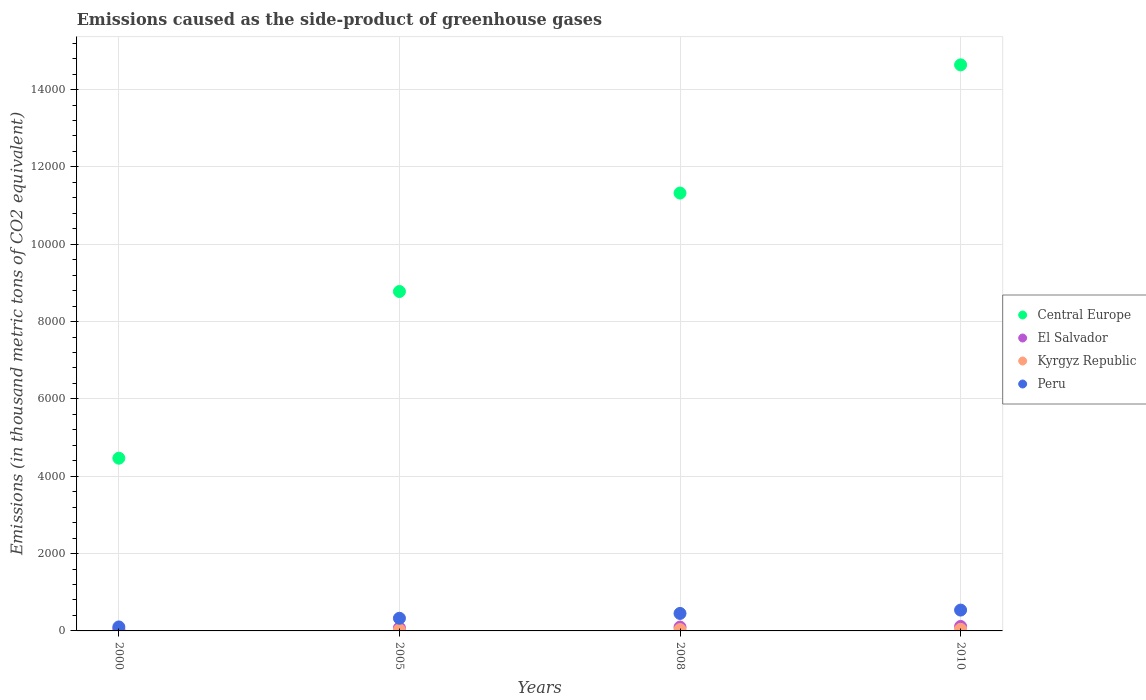Is the number of dotlines equal to the number of legend labels?
Keep it short and to the point. Yes. What is the emissions caused as the side-product of greenhouse gases in Peru in 2005?
Offer a very short reply. 327.6. Across all years, what is the maximum emissions caused as the side-product of greenhouse gases in El Salvador?
Offer a terse response. 116. Across all years, what is the minimum emissions caused as the side-product of greenhouse gases in Kyrgyz Republic?
Keep it short and to the point. 7.9. In which year was the emissions caused as the side-product of greenhouse gases in El Salvador maximum?
Offer a very short reply. 2010. In which year was the emissions caused as the side-product of greenhouse gases in Kyrgyz Republic minimum?
Provide a succinct answer. 2000. What is the total emissions caused as the side-product of greenhouse gases in Kyrgyz Republic in the graph?
Provide a succinct answer. 108.7. What is the difference between the emissions caused as the side-product of greenhouse gases in Central Europe in 2008 and that in 2010?
Make the answer very short. -3315.6. What is the difference between the emissions caused as the side-product of greenhouse gases in Kyrgyz Republic in 2005 and the emissions caused as the side-product of greenhouse gases in Central Europe in 2008?
Your answer should be compact. -1.13e+04. What is the average emissions caused as the side-product of greenhouse gases in El Salvador per year?
Give a very brief answer. 83.35. In the year 2010, what is the difference between the emissions caused as the side-product of greenhouse gases in Central Europe and emissions caused as the side-product of greenhouse gases in Peru?
Offer a terse response. 1.41e+04. What is the ratio of the emissions caused as the side-product of greenhouse gases in El Salvador in 2000 to that in 2008?
Offer a very short reply. 0.42. Is the emissions caused as the side-product of greenhouse gases in Central Europe in 2008 less than that in 2010?
Keep it short and to the point. Yes. Is the difference between the emissions caused as the side-product of greenhouse gases in Central Europe in 2005 and 2010 greater than the difference between the emissions caused as the side-product of greenhouse gases in Peru in 2005 and 2010?
Make the answer very short. No. What is the difference between the highest and the second highest emissions caused as the side-product of greenhouse gases in Central Europe?
Provide a short and direct response. 3315.6. What is the difference between the highest and the lowest emissions caused as the side-product of greenhouse gases in Central Europe?
Your response must be concise. 1.02e+04. In how many years, is the emissions caused as the side-product of greenhouse gases in Kyrgyz Republic greater than the average emissions caused as the side-product of greenhouse gases in Kyrgyz Republic taken over all years?
Your response must be concise. 2. Is it the case that in every year, the sum of the emissions caused as the side-product of greenhouse gases in Central Europe and emissions caused as the side-product of greenhouse gases in Kyrgyz Republic  is greater than the sum of emissions caused as the side-product of greenhouse gases in Peru and emissions caused as the side-product of greenhouse gases in El Salvador?
Your response must be concise. Yes. Is the emissions caused as the side-product of greenhouse gases in Central Europe strictly greater than the emissions caused as the side-product of greenhouse gases in Peru over the years?
Keep it short and to the point. Yes. Is the emissions caused as the side-product of greenhouse gases in Kyrgyz Republic strictly less than the emissions caused as the side-product of greenhouse gases in Peru over the years?
Make the answer very short. Yes. How many dotlines are there?
Offer a very short reply. 4. How many years are there in the graph?
Ensure brevity in your answer.  4. Does the graph contain any zero values?
Offer a terse response. No. How are the legend labels stacked?
Provide a succinct answer. Vertical. What is the title of the graph?
Give a very brief answer. Emissions caused as the side-product of greenhouse gases. What is the label or title of the X-axis?
Give a very brief answer. Years. What is the label or title of the Y-axis?
Your answer should be very brief. Emissions (in thousand metric tons of CO2 equivalent). What is the Emissions (in thousand metric tons of CO2 equivalent) in Central Europe in 2000?
Keep it short and to the point. 4466.9. What is the Emissions (in thousand metric tons of CO2 equivalent) of El Salvador in 2000?
Keep it short and to the point. 41.4. What is the Emissions (in thousand metric tons of CO2 equivalent) of Peru in 2000?
Your response must be concise. 103.1. What is the Emissions (in thousand metric tons of CO2 equivalent) in Central Europe in 2005?
Give a very brief answer. 8777.6. What is the Emissions (in thousand metric tons of CO2 equivalent) of El Salvador in 2005?
Keep it short and to the point. 76.4. What is the Emissions (in thousand metric tons of CO2 equivalent) of Peru in 2005?
Your response must be concise. 327.6. What is the Emissions (in thousand metric tons of CO2 equivalent) of Central Europe in 2008?
Offer a terse response. 1.13e+04. What is the Emissions (in thousand metric tons of CO2 equivalent) of El Salvador in 2008?
Offer a terse response. 99.6. What is the Emissions (in thousand metric tons of CO2 equivalent) in Kyrgyz Republic in 2008?
Give a very brief answer. 34.8. What is the Emissions (in thousand metric tons of CO2 equivalent) of Peru in 2008?
Your response must be concise. 452. What is the Emissions (in thousand metric tons of CO2 equivalent) in Central Europe in 2010?
Offer a terse response. 1.46e+04. What is the Emissions (in thousand metric tons of CO2 equivalent) of El Salvador in 2010?
Your answer should be very brief. 116. What is the Emissions (in thousand metric tons of CO2 equivalent) in Peru in 2010?
Provide a succinct answer. 539. Across all years, what is the maximum Emissions (in thousand metric tons of CO2 equivalent) in Central Europe?
Keep it short and to the point. 1.46e+04. Across all years, what is the maximum Emissions (in thousand metric tons of CO2 equivalent) of El Salvador?
Provide a succinct answer. 116. Across all years, what is the maximum Emissions (in thousand metric tons of CO2 equivalent) of Kyrgyz Republic?
Keep it short and to the point. 42. Across all years, what is the maximum Emissions (in thousand metric tons of CO2 equivalent) of Peru?
Ensure brevity in your answer.  539. Across all years, what is the minimum Emissions (in thousand metric tons of CO2 equivalent) of Central Europe?
Give a very brief answer. 4466.9. Across all years, what is the minimum Emissions (in thousand metric tons of CO2 equivalent) in El Salvador?
Offer a very short reply. 41.4. Across all years, what is the minimum Emissions (in thousand metric tons of CO2 equivalent) of Kyrgyz Republic?
Provide a succinct answer. 7.9. Across all years, what is the minimum Emissions (in thousand metric tons of CO2 equivalent) of Peru?
Provide a succinct answer. 103.1. What is the total Emissions (in thousand metric tons of CO2 equivalent) of Central Europe in the graph?
Give a very brief answer. 3.92e+04. What is the total Emissions (in thousand metric tons of CO2 equivalent) of El Salvador in the graph?
Provide a succinct answer. 333.4. What is the total Emissions (in thousand metric tons of CO2 equivalent) in Kyrgyz Republic in the graph?
Your response must be concise. 108.7. What is the total Emissions (in thousand metric tons of CO2 equivalent) in Peru in the graph?
Your answer should be compact. 1421.7. What is the difference between the Emissions (in thousand metric tons of CO2 equivalent) of Central Europe in 2000 and that in 2005?
Offer a terse response. -4310.7. What is the difference between the Emissions (in thousand metric tons of CO2 equivalent) of El Salvador in 2000 and that in 2005?
Provide a succinct answer. -35. What is the difference between the Emissions (in thousand metric tons of CO2 equivalent) of Kyrgyz Republic in 2000 and that in 2005?
Keep it short and to the point. -16.1. What is the difference between the Emissions (in thousand metric tons of CO2 equivalent) of Peru in 2000 and that in 2005?
Ensure brevity in your answer.  -224.5. What is the difference between the Emissions (in thousand metric tons of CO2 equivalent) in Central Europe in 2000 and that in 2008?
Ensure brevity in your answer.  -6856.5. What is the difference between the Emissions (in thousand metric tons of CO2 equivalent) in El Salvador in 2000 and that in 2008?
Give a very brief answer. -58.2. What is the difference between the Emissions (in thousand metric tons of CO2 equivalent) in Kyrgyz Republic in 2000 and that in 2008?
Ensure brevity in your answer.  -26.9. What is the difference between the Emissions (in thousand metric tons of CO2 equivalent) of Peru in 2000 and that in 2008?
Your answer should be very brief. -348.9. What is the difference between the Emissions (in thousand metric tons of CO2 equivalent) of Central Europe in 2000 and that in 2010?
Offer a terse response. -1.02e+04. What is the difference between the Emissions (in thousand metric tons of CO2 equivalent) in El Salvador in 2000 and that in 2010?
Your response must be concise. -74.6. What is the difference between the Emissions (in thousand metric tons of CO2 equivalent) in Kyrgyz Republic in 2000 and that in 2010?
Keep it short and to the point. -34.1. What is the difference between the Emissions (in thousand metric tons of CO2 equivalent) in Peru in 2000 and that in 2010?
Give a very brief answer. -435.9. What is the difference between the Emissions (in thousand metric tons of CO2 equivalent) in Central Europe in 2005 and that in 2008?
Provide a short and direct response. -2545.8. What is the difference between the Emissions (in thousand metric tons of CO2 equivalent) of El Salvador in 2005 and that in 2008?
Offer a terse response. -23.2. What is the difference between the Emissions (in thousand metric tons of CO2 equivalent) of Kyrgyz Republic in 2005 and that in 2008?
Make the answer very short. -10.8. What is the difference between the Emissions (in thousand metric tons of CO2 equivalent) of Peru in 2005 and that in 2008?
Make the answer very short. -124.4. What is the difference between the Emissions (in thousand metric tons of CO2 equivalent) of Central Europe in 2005 and that in 2010?
Offer a very short reply. -5861.4. What is the difference between the Emissions (in thousand metric tons of CO2 equivalent) of El Salvador in 2005 and that in 2010?
Offer a very short reply. -39.6. What is the difference between the Emissions (in thousand metric tons of CO2 equivalent) of Kyrgyz Republic in 2005 and that in 2010?
Your response must be concise. -18. What is the difference between the Emissions (in thousand metric tons of CO2 equivalent) in Peru in 2005 and that in 2010?
Your answer should be very brief. -211.4. What is the difference between the Emissions (in thousand metric tons of CO2 equivalent) of Central Europe in 2008 and that in 2010?
Make the answer very short. -3315.6. What is the difference between the Emissions (in thousand metric tons of CO2 equivalent) in El Salvador in 2008 and that in 2010?
Keep it short and to the point. -16.4. What is the difference between the Emissions (in thousand metric tons of CO2 equivalent) of Peru in 2008 and that in 2010?
Keep it short and to the point. -87. What is the difference between the Emissions (in thousand metric tons of CO2 equivalent) of Central Europe in 2000 and the Emissions (in thousand metric tons of CO2 equivalent) of El Salvador in 2005?
Give a very brief answer. 4390.5. What is the difference between the Emissions (in thousand metric tons of CO2 equivalent) of Central Europe in 2000 and the Emissions (in thousand metric tons of CO2 equivalent) of Kyrgyz Republic in 2005?
Provide a short and direct response. 4442.9. What is the difference between the Emissions (in thousand metric tons of CO2 equivalent) of Central Europe in 2000 and the Emissions (in thousand metric tons of CO2 equivalent) of Peru in 2005?
Offer a terse response. 4139.3. What is the difference between the Emissions (in thousand metric tons of CO2 equivalent) of El Salvador in 2000 and the Emissions (in thousand metric tons of CO2 equivalent) of Kyrgyz Republic in 2005?
Offer a very short reply. 17.4. What is the difference between the Emissions (in thousand metric tons of CO2 equivalent) of El Salvador in 2000 and the Emissions (in thousand metric tons of CO2 equivalent) of Peru in 2005?
Give a very brief answer. -286.2. What is the difference between the Emissions (in thousand metric tons of CO2 equivalent) of Kyrgyz Republic in 2000 and the Emissions (in thousand metric tons of CO2 equivalent) of Peru in 2005?
Give a very brief answer. -319.7. What is the difference between the Emissions (in thousand metric tons of CO2 equivalent) in Central Europe in 2000 and the Emissions (in thousand metric tons of CO2 equivalent) in El Salvador in 2008?
Give a very brief answer. 4367.3. What is the difference between the Emissions (in thousand metric tons of CO2 equivalent) in Central Europe in 2000 and the Emissions (in thousand metric tons of CO2 equivalent) in Kyrgyz Republic in 2008?
Ensure brevity in your answer.  4432.1. What is the difference between the Emissions (in thousand metric tons of CO2 equivalent) in Central Europe in 2000 and the Emissions (in thousand metric tons of CO2 equivalent) in Peru in 2008?
Provide a short and direct response. 4014.9. What is the difference between the Emissions (in thousand metric tons of CO2 equivalent) in El Salvador in 2000 and the Emissions (in thousand metric tons of CO2 equivalent) in Kyrgyz Republic in 2008?
Ensure brevity in your answer.  6.6. What is the difference between the Emissions (in thousand metric tons of CO2 equivalent) in El Salvador in 2000 and the Emissions (in thousand metric tons of CO2 equivalent) in Peru in 2008?
Give a very brief answer. -410.6. What is the difference between the Emissions (in thousand metric tons of CO2 equivalent) in Kyrgyz Republic in 2000 and the Emissions (in thousand metric tons of CO2 equivalent) in Peru in 2008?
Make the answer very short. -444.1. What is the difference between the Emissions (in thousand metric tons of CO2 equivalent) of Central Europe in 2000 and the Emissions (in thousand metric tons of CO2 equivalent) of El Salvador in 2010?
Your response must be concise. 4350.9. What is the difference between the Emissions (in thousand metric tons of CO2 equivalent) in Central Europe in 2000 and the Emissions (in thousand metric tons of CO2 equivalent) in Kyrgyz Republic in 2010?
Offer a very short reply. 4424.9. What is the difference between the Emissions (in thousand metric tons of CO2 equivalent) in Central Europe in 2000 and the Emissions (in thousand metric tons of CO2 equivalent) in Peru in 2010?
Make the answer very short. 3927.9. What is the difference between the Emissions (in thousand metric tons of CO2 equivalent) in El Salvador in 2000 and the Emissions (in thousand metric tons of CO2 equivalent) in Peru in 2010?
Provide a succinct answer. -497.6. What is the difference between the Emissions (in thousand metric tons of CO2 equivalent) of Kyrgyz Republic in 2000 and the Emissions (in thousand metric tons of CO2 equivalent) of Peru in 2010?
Provide a succinct answer. -531.1. What is the difference between the Emissions (in thousand metric tons of CO2 equivalent) in Central Europe in 2005 and the Emissions (in thousand metric tons of CO2 equivalent) in El Salvador in 2008?
Provide a short and direct response. 8678. What is the difference between the Emissions (in thousand metric tons of CO2 equivalent) of Central Europe in 2005 and the Emissions (in thousand metric tons of CO2 equivalent) of Kyrgyz Republic in 2008?
Provide a succinct answer. 8742.8. What is the difference between the Emissions (in thousand metric tons of CO2 equivalent) in Central Europe in 2005 and the Emissions (in thousand metric tons of CO2 equivalent) in Peru in 2008?
Give a very brief answer. 8325.6. What is the difference between the Emissions (in thousand metric tons of CO2 equivalent) in El Salvador in 2005 and the Emissions (in thousand metric tons of CO2 equivalent) in Kyrgyz Republic in 2008?
Make the answer very short. 41.6. What is the difference between the Emissions (in thousand metric tons of CO2 equivalent) in El Salvador in 2005 and the Emissions (in thousand metric tons of CO2 equivalent) in Peru in 2008?
Ensure brevity in your answer.  -375.6. What is the difference between the Emissions (in thousand metric tons of CO2 equivalent) in Kyrgyz Republic in 2005 and the Emissions (in thousand metric tons of CO2 equivalent) in Peru in 2008?
Offer a very short reply. -428. What is the difference between the Emissions (in thousand metric tons of CO2 equivalent) of Central Europe in 2005 and the Emissions (in thousand metric tons of CO2 equivalent) of El Salvador in 2010?
Offer a very short reply. 8661.6. What is the difference between the Emissions (in thousand metric tons of CO2 equivalent) in Central Europe in 2005 and the Emissions (in thousand metric tons of CO2 equivalent) in Kyrgyz Republic in 2010?
Your answer should be compact. 8735.6. What is the difference between the Emissions (in thousand metric tons of CO2 equivalent) of Central Europe in 2005 and the Emissions (in thousand metric tons of CO2 equivalent) of Peru in 2010?
Ensure brevity in your answer.  8238.6. What is the difference between the Emissions (in thousand metric tons of CO2 equivalent) in El Salvador in 2005 and the Emissions (in thousand metric tons of CO2 equivalent) in Kyrgyz Republic in 2010?
Provide a short and direct response. 34.4. What is the difference between the Emissions (in thousand metric tons of CO2 equivalent) of El Salvador in 2005 and the Emissions (in thousand metric tons of CO2 equivalent) of Peru in 2010?
Provide a short and direct response. -462.6. What is the difference between the Emissions (in thousand metric tons of CO2 equivalent) in Kyrgyz Republic in 2005 and the Emissions (in thousand metric tons of CO2 equivalent) in Peru in 2010?
Your answer should be compact. -515. What is the difference between the Emissions (in thousand metric tons of CO2 equivalent) of Central Europe in 2008 and the Emissions (in thousand metric tons of CO2 equivalent) of El Salvador in 2010?
Ensure brevity in your answer.  1.12e+04. What is the difference between the Emissions (in thousand metric tons of CO2 equivalent) in Central Europe in 2008 and the Emissions (in thousand metric tons of CO2 equivalent) in Kyrgyz Republic in 2010?
Your answer should be compact. 1.13e+04. What is the difference between the Emissions (in thousand metric tons of CO2 equivalent) in Central Europe in 2008 and the Emissions (in thousand metric tons of CO2 equivalent) in Peru in 2010?
Your answer should be very brief. 1.08e+04. What is the difference between the Emissions (in thousand metric tons of CO2 equivalent) of El Salvador in 2008 and the Emissions (in thousand metric tons of CO2 equivalent) of Kyrgyz Republic in 2010?
Ensure brevity in your answer.  57.6. What is the difference between the Emissions (in thousand metric tons of CO2 equivalent) in El Salvador in 2008 and the Emissions (in thousand metric tons of CO2 equivalent) in Peru in 2010?
Offer a terse response. -439.4. What is the difference between the Emissions (in thousand metric tons of CO2 equivalent) of Kyrgyz Republic in 2008 and the Emissions (in thousand metric tons of CO2 equivalent) of Peru in 2010?
Keep it short and to the point. -504.2. What is the average Emissions (in thousand metric tons of CO2 equivalent) of Central Europe per year?
Provide a short and direct response. 9801.73. What is the average Emissions (in thousand metric tons of CO2 equivalent) of El Salvador per year?
Offer a terse response. 83.35. What is the average Emissions (in thousand metric tons of CO2 equivalent) in Kyrgyz Republic per year?
Offer a terse response. 27.18. What is the average Emissions (in thousand metric tons of CO2 equivalent) in Peru per year?
Keep it short and to the point. 355.43. In the year 2000, what is the difference between the Emissions (in thousand metric tons of CO2 equivalent) in Central Europe and Emissions (in thousand metric tons of CO2 equivalent) in El Salvador?
Make the answer very short. 4425.5. In the year 2000, what is the difference between the Emissions (in thousand metric tons of CO2 equivalent) of Central Europe and Emissions (in thousand metric tons of CO2 equivalent) of Kyrgyz Republic?
Offer a very short reply. 4459. In the year 2000, what is the difference between the Emissions (in thousand metric tons of CO2 equivalent) in Central Europe and Emissions (in thousand metric tons of CO2 equivalent) in Peru?
Ensure brevity in your answer.  4363.8. In the year 2000, what is the difference between the Emissions (in thousand metric tons of CO2 equivalent) of El Salvador and Emissions (in thousand metric tons of CO2 equivalent) of Kyrgyz Republic?
Your answer should be compact. 33.5. In the year 2000, what is the difference between the Emissions (in thousand metric tons of CO2 equivalent) in El Salvador and Emissions (in thousand metric tons of CO2 equivalent) in Peru?
Offer a very short reply. -61.7. In the year 2000, what is the difference between the Emissions (in thousand metric tons of CO2 equivalent) of Kyrgyz Republic and Emissions (in thousand metric tons of CO2 equivalent) of Peru?
Offer a terse response. -95.2. In the year 2005, what is the difference between the Emissions (in thousand metric tons of CO2 equivalent) of Central Europe and Emissions (in thousand metric tons of CO2 equivalent) of El Salvador?
Make the answer very short. 8701.2. In the year 2005, what is the difference between the Emissions (in thousand metric tons of CO2 equivalent) of Central Europe and Emissions (in thousand metric tons of CO2 equivalent) of Kyrgyz Republic?
Your response must be concise. 8753.6. In the year 2005, what is the difference between the Emissions (in thousand metric tons of CO2 equivalent) in Central Europe and Emissions (in thousand metric tons of CO2 equivalent) in Peru?
Ensure brevity in your answer.  8450. In the year 2005, what is the difference between the Emissions (in thousand metric tons of CO2 equivalent) of El Salvador and Emissions (in thousand metric tons of CO2 equivalent) of Kyrgyz Republic?
Your answer should be very brief. 52.4. In the year 2005, what is the difference between the Emissions (in thousand metric tons of CO2 equivalent) of El Salvador and Emissions (in thousand metric tons of CO2 equivalent) of Peru?
Offer a very short reply. -251.2. In the year 2005, what is the difference between the Emissions (in thousand metric tons of CO2 equivalent) of Kyrgyz Republic and Emissions (in thousand metric tons of CO2 equivalent) of Peru?
Make the answer very short. -303.6. In the year 2008, what is the difference between the Emissions (in thousand metric tons of CO2 equivalent) of Central Europe and Emissions (in thousand metric tons of CO2 equivalent) of El Salvador?
Your answer should be compact. 1.12e+04. In the year 2008, what is the difference between the Emissions (in thousand metric tons of CO2 equivalent) of Central Europe and Emissions (in thousand metric tons of CO2 equivalent) of Kyrgyz Republic?
Provide a short and direct response. 1.13e+04. In the year 2008, what is the difference between the Emissions (in thousand metric tons of CO2 equivalent) in Central Europe and Emissions (in thousand metric tons of CO2 equivalent) in Peru?
Your answer should be very brief. 1.09e+04. In the year 2008, what is the difference between the Emissions (in thousand metric tons of CO2 equivalent) of El Salvador and Emissions (in thousand metric tons of CO2 equivalent) of Kyrgyz Republic?
Keep it short and to the point. 64.8. In the year 2008, what is the difference between the Emissions (in thousand metric tons of CO2 equivalent) of El Salvador and Emissions (in thousand metric tons of CO2 equivalent) of Peru?
Ensure brevity in your answer.  -352.4. In the year 2008, what is the difference between the Emissions (in thousand metric tons of CO2 equivalent) of Kyrgyz Republic and Emissions (in thousand metric tons of CO2 equivalent) of Peru?
Provide a short and direct response. -417.2. In the year 2010, what is the difference between the Emissions (in thousand metric tons of CO2 equivalent) in Central Europe and Emissions (in thousand metric tons of CO2 equivalent) in El Salvador?
Your answer should be compact. 1.45e+04. In the year 2010, what is the difference between the Emissions (in thousand metric tons of CO2 equivalent) in Central Europe and Emissions (in thousand metric tons of CO2 equivalent) in Kyrgyz Republic?
Your answer should be very brief. 1.46e+04. In the year 2010, what is the difference between the Emissions (in thousand metric tons of CO2 equivalent) of Central Europe and Emissions (in thousand metric tons of CO2 equivalent) of Peru?
Offer a terse response. 1.41e+04. In the year 2010, what is the difference between the Emissions (in thousand metric tons of CO2 equivalent) in El Salvador and Emissions (in thousand metric tons of CO2 equivalent) in Kyrgyz Republic?
Keep it short and to the point. 74. In the year 2010, what is the difference between the Emissions (in thousand metric tons of CO2 equivalent) of El Salvador and Emissions (in thousand metric tons of CO2 equivalent) of Peru?
Make the answer very short. -423. In the year 2010, what is the difference between the Emissions (in thousand metric tons of CO2 equivalent) of Kyrgyz Republic and Emissions (in thousand metric tons of CO2 equivalent) of Peru?
Make the answer very short. -497. What is the ratio of the Emissions (in thousand metric tons of CO2 equivalent) in Central Europe in 2000 to that in 2005?
Keep it short and to the point. 0.51. What is the ratio of the Emissions (in thousand metric tons of CO2 equivalent) in El Salvador in 2000 to that in 2005?
Make the answer very short. 0.54. What is the ratio of the Emissions (in thousand metric tons of CO2 equivalent) in Kyrgyz Republic in 2000 to that in 2005?
Offer a very short reply. 0.33. What is the ratio of the Emissions (in thousand metric tons of CO2 equivalent) in Peru in 2000 to that in 2005?
Ensure brevity in your answer.  0.31. What is the ratio of the Emissions (in thousand metric tons of CO2 equivalent) in Central Europe in 2000 to that in 2008?
Offer a very short reply. 0.39. What is the ratio of the Emissions (in thousand metric tons of CO2 equivalent) in El Salvador in 2000 to that in 2008?
Give a very brief answer. 0.42. What is the ratio of the Emissions (in thousand metric tons of CO2 equivalent) in Kyrgyz Republic in 2000 to that in 2008?
Keep it short and to the point. 0.23. What is the ratio of the Emissions (in thousand metric tons of CO2 equivalent) in Peru in 2000 to that in 2008?
Provide a short and direct response. 0.23. What is the ratio of the Emissions (in thousand metric tons of CO2 equivalent) of Central Europe in 2000 to that in 2010?
Keep it short and to the point. 0.31. What is the ratio of the Emissions (in thousand metric tons of CO2 equivalent) of El Salvador in 2000 to that in 2010?
Provide a short and direct response. 0.36. What is the ratio of the Emissions (in thousand metric tons of CO2 equivalent) in Kyrgyz Republic in 2000 to that in 2010?
Provide a succinct answer. 0.19. What is the ratio of the Emissions (in thousand metric tons of CO2 equivalent) in Peru in 2000 to that in 2010?
Provide a succinct answer. 0.19. What is the ratio of the Emissions (in thousand metric tons of CO2 equivalent) in Central Europe in 2005 to that in 2008?
Offer a very short reply. 0.78. What is the ratio of the Emissions (in thousand metric tons of CO2 equivalent) in El Salvador in 2005 to that in 2008?
Keep it short and to the point. 0.77. What is the ratio of the Emissions (in thousand metric tons of CO2 equivalent) in Kyrgyz Republic in 2005 to that in 2008?
Your answer should be very brief. 0.69. What is the ratio of the Emissions (in thousand metric tons of CO2 equivalent) in Peru in 2005 to that in 2008?
Provide a short and direct response. 0.72. What is the ratio of the Emissions (in thousand metric tons of CO2 equivalent) in Central Europe in 2005 to that in 2010?
Offer a very short reply. 0.6. What is the ratio of the Emissions (in thousand metric tons of CO2 equivalent) of El Salvador in 2005 to that in 2010?
Make the answer very short. 0.66. What is the ratio of the Emissions (in thousand metric tons of CO2 equivalent) of Peru in 2005 to that in 2010?
Make the answer very short. 0.61. What is the ratio of the Emissions (in thousand metric tons of CO2 equivalent) in Central Europe in 2008 to that in 2010?
Give a very brief answer. 0.77. What is the ratio of the Emissions (in thousand metric tons of CO2 equivalent) in El Salvador in 2008 to that in 2010?
Provide a succinct answer. 0.86. What is the ratio of the Emissions (in thousand metric tons of CO2 equivalent) of Kyrgyz Republic in 2008 to that in 2010?
Provide a succinct answer. 0.83. What is the ratio of the Emissions (in thousand metric tons of CO2 equivalent) in Peru in 2008 to that in 2010?
Ensure brevity in your answer.  0.84. What is the difference between the highest and the second highest Emissions (in thousand metric tons of CO2 equivalent) of Central Europe?
Your answer should be very brief. 3315.6. What is the difference between the highest and the second highest Emissions (in thousand metric tons of CO2 equivalent) in El Salvador?
Offer a very short reply. 16.4. What is the difference between the highest and the second highest Emissions (in thousand metric tons of CO2 equivalent) in Kyrgyz Republic?
Make the answer very short. 7.2. What is the difference between the highest and the second highest Emissions (in thousand metric tons of CO2 equivalent) of Peru?
Give a very brief answer. 87. What is the difference between the highest and the lowest Emissions (in thousand metric tons of CO2 equivalent) of Central Europe?
Your answer should be very brief. 1.02e+04. What is the difference between the highest and the lowest Emissions (in thousand metric tons of CO2 equivalent) of El Salvador?
Your response must be concise. 74.6. What is the difference between the highest and the lowest Emissions (in thousand metric tons of CO2 equivalent) of Kyrgyz Republic?
Provide a short and direct response. 34.1. What is the difference between the highest and the lowest Emissions (in thousand metric tons of CO2 equivalent) of Peru?
Your answer should be compact. 435.9. 